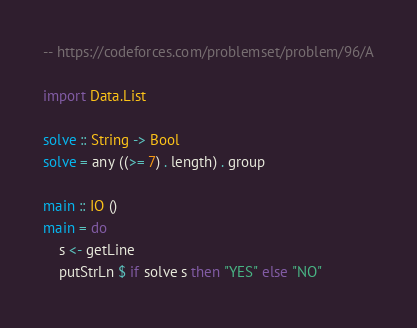Convert code to text. <code><loc_0><loc_0><loc_500><loc_500><_Haskell_>-- https://codeforces.com/problemset/problem/96/A

import Data.List

solve :: String -> Bool
solve = any ((>= 7) . length) . group

main :: IO ()
main = do
    s <- getLine
    putStrLn $ if solve s then "YES" else "NO"

</code> 